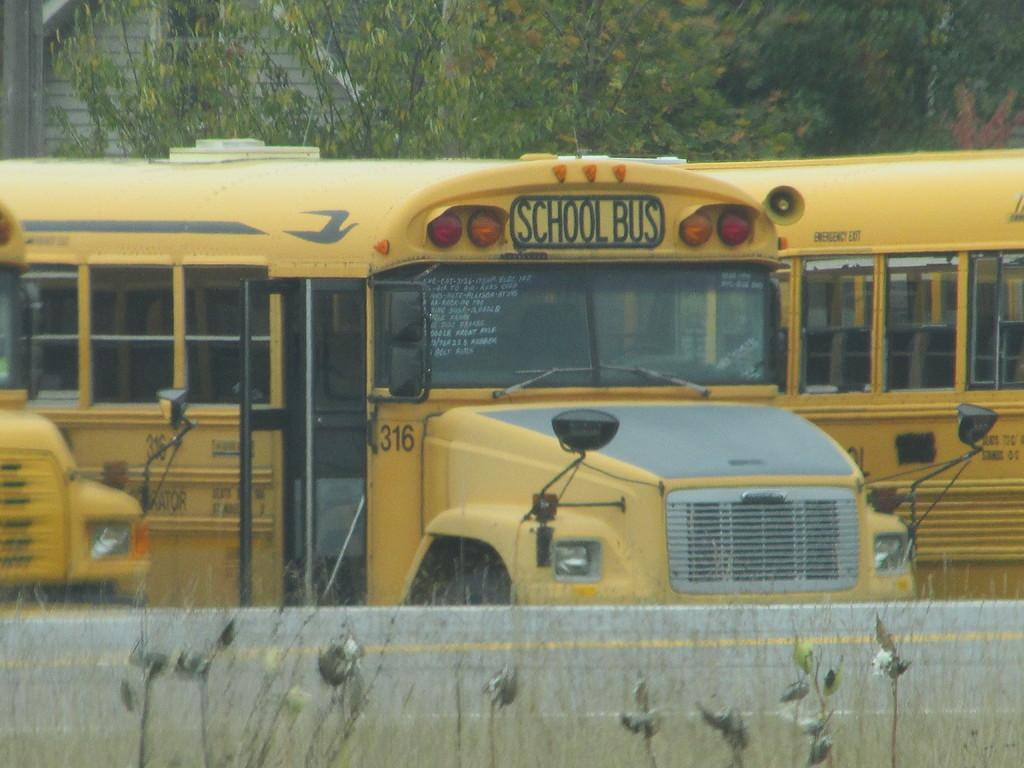What type of vehicles are in the image? There are school buses in the image. What color are the school buses? The school buses are yellow. What is depicted at the bottom of the image? There are planets depicted at the bottom of the image. What is present in the image that might serve as a barrier or divider? There is a wall in the image. What can be seen in the background of the image? There are trees in the background of the image. What type of calculator is being used by the father in the image? There is no father or calculator present in the image. What is the net used for in the image? There is no net present in the image. 